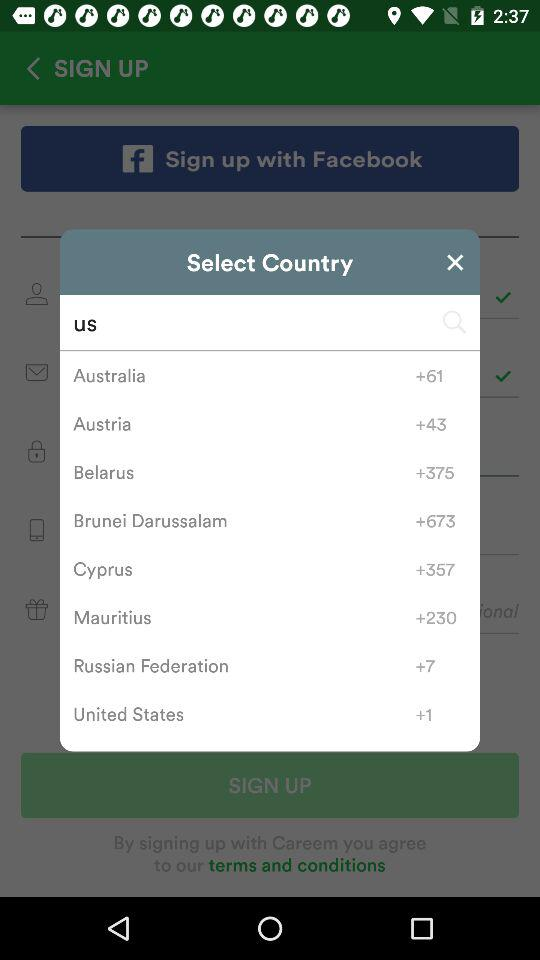What is the text entered in the search bar? The entered text is "us". 